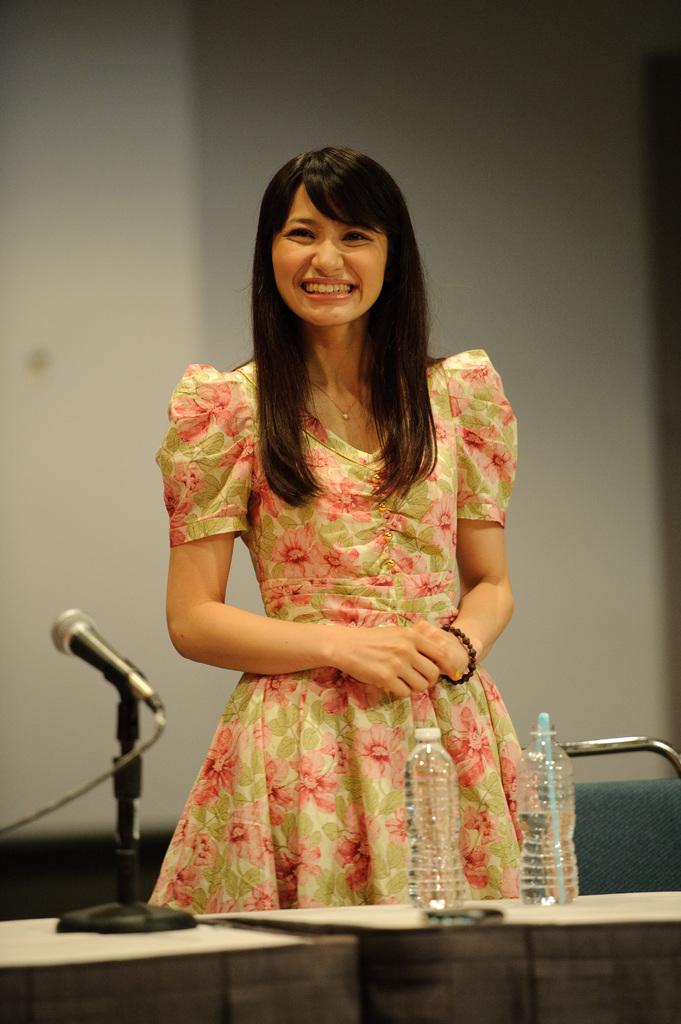What is the main subject in the image? There is a woman standing in the image. What can be seen in the background of the image? There is a wall in the background of the image. What is on the table in the image? A microphone stand and bottles are present on the table. What piece of furniture is on the right side of the image? There is a chair on the right side of the image. Can you tell me how many dinosaurs are visible in the image? There are no dinosaurs present in the image. What type of range is being used by the woman in the image? There is no range visible in the image, and the woman is not using any equipment that would require a range. 